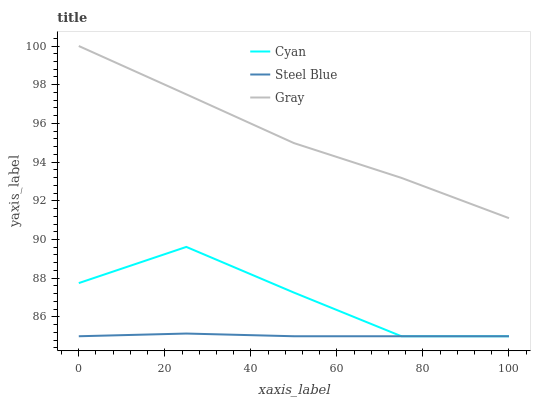Does Gray have the minimum area under the curve?
Answer yes or no. No. Does Steel Blue have the maximum area under the curve?
Answer yes or no. No. Is Gray the smoothest?
Answer yes or no. No. Is Gray the roughest?
Answer yes or no. No. Does Gray have the lowest value?
Answer yes or no. No. Does Steel Blue have the highest value?
Answer yes or no. No. Is Steel Blue less than Gray?
Answer yes or no. Yes. Is Gray greater than Cyan?
Answer yes or no. Yes. Does Steel Blue intersect Gray?
Answer yes or no. No. 